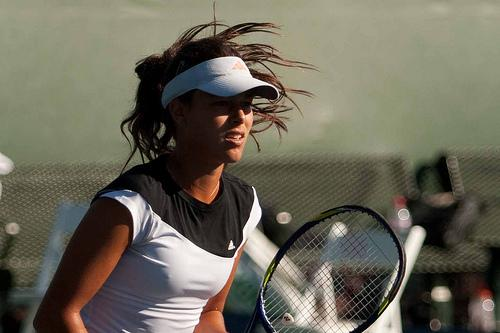Question: what is the woman holding?
Choices:
A. A basketball.
B. A tennis ball.
C. A baseball.
D. Tennis racket.
Answer with the letter. Answer: D Question: what color is the court?
Choices:
A. Yellow.
B. Green.
C. Blue.
D. Red.
Answer with the letter. Answer: B Question: where was this photographed?
Choices:
A. Basketball court.
B. Tennis court.
C. A gym.
D. A volleyball court.
Answer with the letter. Answer: B 